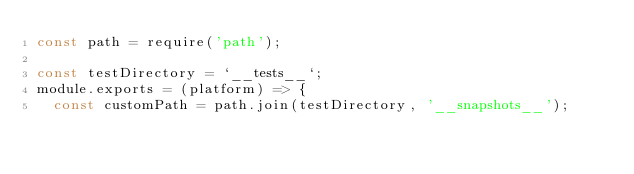Convert code to text. <code><loc_0><loc_0><loc_500><loc_500><_JavaScript_>const path = require('path');

const testDirectory = `__tests__`;
module.exports = (platform) => {
  const customPath = path.join(testDirectory, '__snapshots__');</code> 